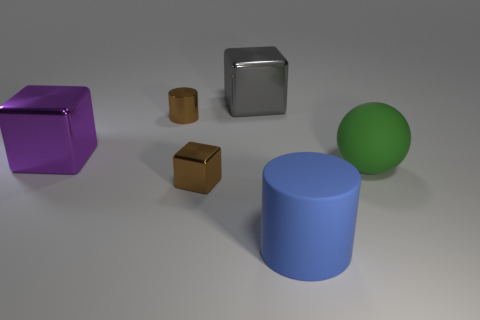Is there any particular source of lighting in the image, or does it seem to come from multiple directions? The shadows and highlights on the objects suggest a diffuse overhead lighting setup with no hard shadows, indicating soft, uniformly spread light from multiple directions or a singular, large, and diffused overhead source. This lighting creates soft shadows and subtle reflections, enhancing the three-dimensional feel of the scene. 